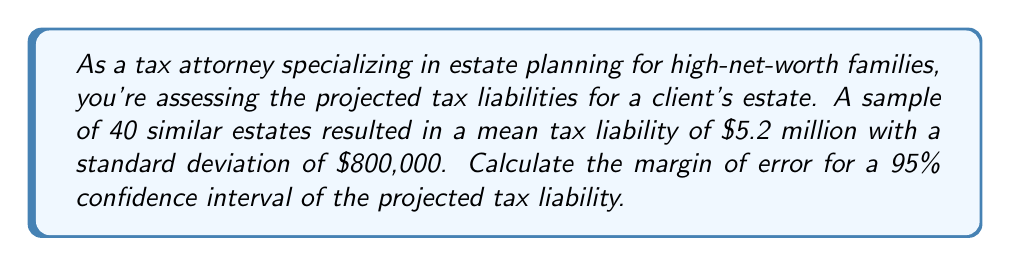What is the answer to this math problem? To calculate the margin of error for a 95% confidence interval, we'll follow these steps:

1) The formula for margin of error is:

   $$ ME = z * \frac{\sigma}{\sqrt{n}} $$

   Where:
   $z$ is the z-score for the desired confidence level
   $\sigma$ is the standard deviation
   $n$ is the sample size

2) For a 95% confidence interval, the z-score is 1.96.

3) We're given:
   $\sigma = 800,000$
   $n = 40$

4) Substituting these values into the formula:

   $$ ME = 1.96 * \frac{800,000}{\sqrt{40}} $$

5) Simplify:
   $$ ME = 1.96 * \frac{800,000}{6.325} $$

6) Calculate:
   $$ ME = 1.96 * 126,486 \approx 247,912 $$

7) Round to the nearest thousand for practical use in tax planning:
   $$ ME \approx 248,000 $$

This means we can be 95% confident that the true mean tax liability for similar estates falls within $248,000 of our sample mean.
Answer: $248,000 